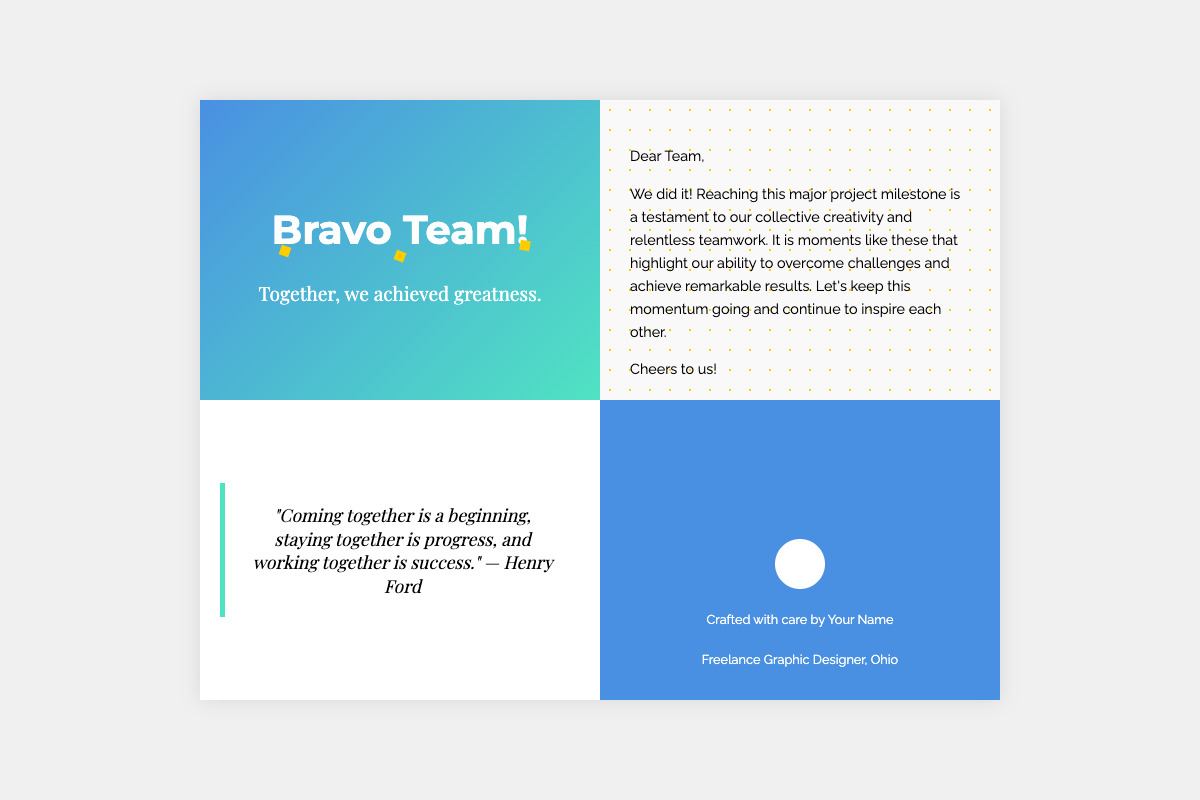What is the title of the card? The title of the card is prominently displayed at the top of the front cover.
Answer: Celebrating a Major Milestone! Who is the card addressed to? The card includes a greeting directed towards a collective group, indicated in the inside left section.
Answer: Dear Team What quote is featured inside the card? The quote can be found in the inside right section, attributed to a well-known individual.
Answer: "Coming together is a beginning, staying together is progress, and working together is success." — Henry Ford What is the main color theme of the front cover? The front cover features a gradient background blending two specific colors.
Answer: Blue and green What profession is specified on the back cover? The profession of the creator of the card is mentioned on the back cover.
Answer: Freelance Graphic Designer What message is conveyed in the inside left section? This message summarizes the sentiment about reaching the project milestone and teamwork.
Answer: We did it! Reaching this major project milestone What is said about team spirit in the card? The card communicates the value of teamwork and creativity as essential to achieving milestones.
Answer: Testament to our collective creativity and relentless teamwork What decorative elements are used on the front cover? The card incorporates specific visual elements that contribute to its celebratory theme.
Answer: Confetti and abstract shapes 